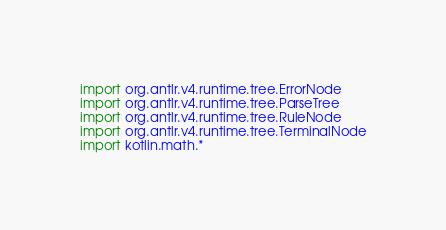<code> <loc_0><loc_0><loc_500><loc_500><_Kotlin_>import org.antlr.v4.runtime.tree.ErrorNode
import org.antlr.v4.runtime.tree.ParseTree
import org.antlr.v4.runtime.tree.RuleNode
import org.antlr.v4.runtime.tree.TerminalNode
import kotlin.math.*
</code> 